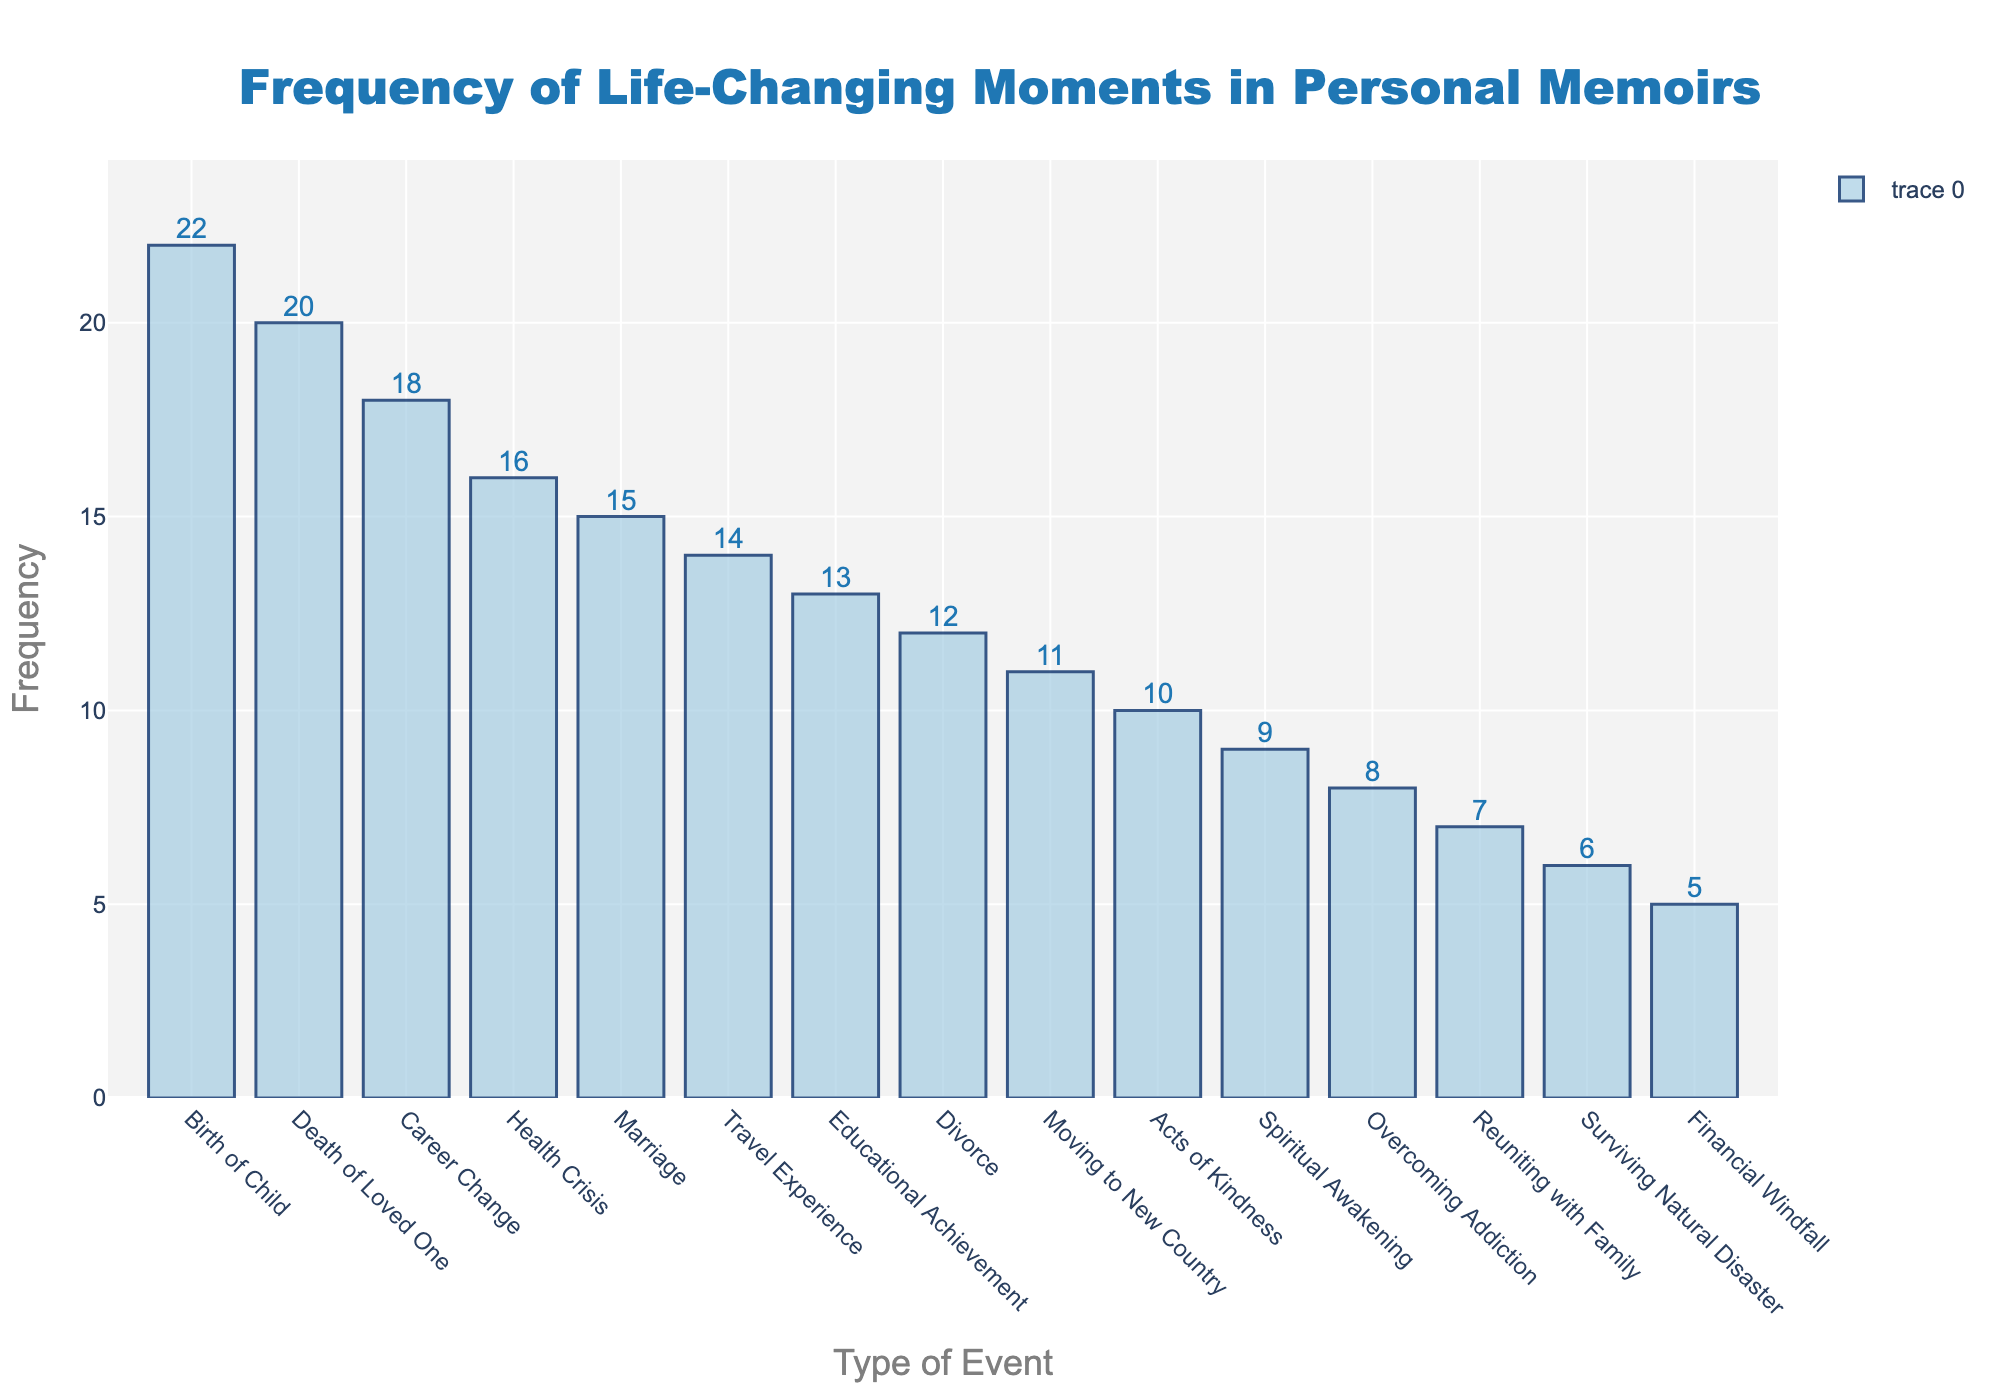how many types of events are shown in the figure? Count the total number of distinct event types listed along the x-axis. There are 15 different events listed.
Answer: 15 what is the title of the figure? Look at the top of the figure for the text that summarizes what has been plotted. The title is "Frequency of Life-Changing Moments in Personal Memoirs."
Answer: Frequency of Life-Changing Moments in Personal Memoirs which event type has the highest frequency? Identify the tallest bar in the histogram and read its label. The tallest bar corresponds to "Birth of Child" with a frequency of 22.
Answer: Birth of Child what is the frequency of career change events? Locate the "Career Change" event on the x-axis and note the height of its bar, which represents its frequency. The frequency is 18.
Answer: 18 which event type has the lowest frequency? Identify the shortest bar in the histogram and read its label. The shortest bar corresponds to "Financial Windfall" with a frequency of 5.
Answer: Financial Windfall how many events have a frequency greater than 15? Count the number of bars in the histogram that exceed the frequency value of 15. Four events have a frequency greater than 15.
Answer: 4 what is the average frequency of the events? Sum the frequencies of all the events and divide by the number of event types (15). The total frequency sum is 216, so the average frequency is 216 / 15 = 14.4.
Answer: 14.4 how much higher is the frequency of the Birth of Child compared to the frequency of Divorces? Subtract the frequency of Divorces (12) from the frequency of the Birth of Child (22). The difference is 22 - 12 = 10.
Answer: 10 which events have a frequency between 10 and 15 inclusive? Identify the events whose bars fall between the frequencies of 10 and 15. These events are "Travel Experience", "Educational Achievement", "Acts of Kindness", "Moving to New Country", "Divorce", and "Reuniting with Family".
Answer: Travel Experience, Educational Achievement, Acts of Kindness, Moving to New Country, Divorce, Reuniting with Family do more events have a frequency below or above 10? Count the number of events with frequencies below and above 10, respectively. Six events are above 10 and nine events are below 10.
Answer: below 